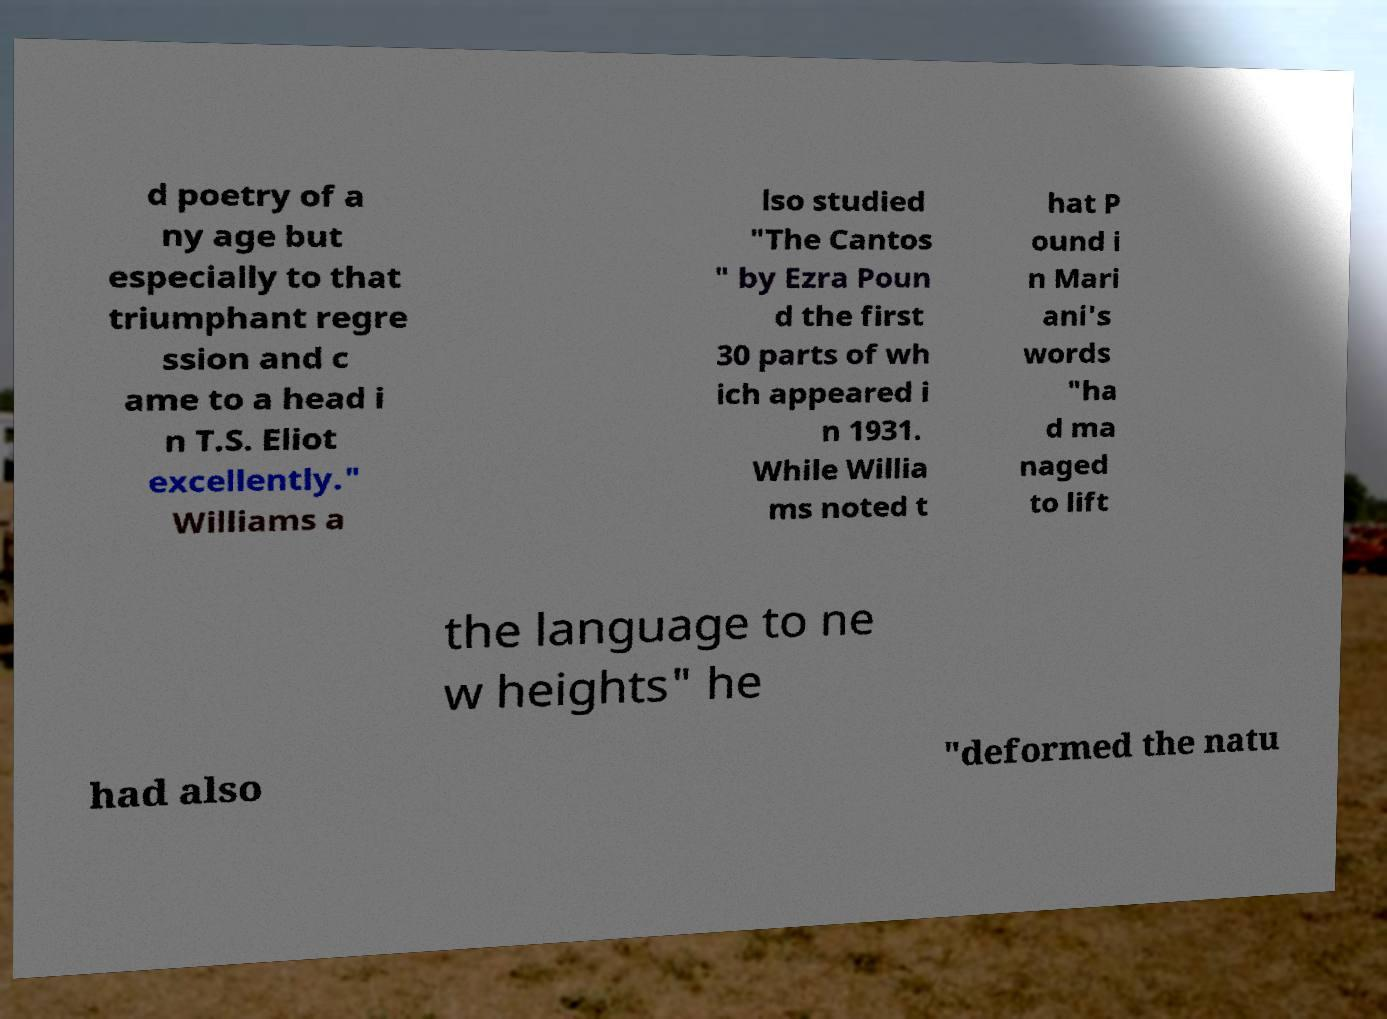Can you accurately transcribe the text from the provided image for me? d poetry of a ny age but especially to that triumphant regre ssion and c ame to a head i n T.S. Eliot excellently." Williams a lso studied "The Cantos " by Ezra Poun d the first 30 parts of wh ich appeared i n 1931. While Willia ms noted t hat P ound i n Mari ani's words "ha d ma naged to lift the language to ne w heights" he had also "deformed the natu 